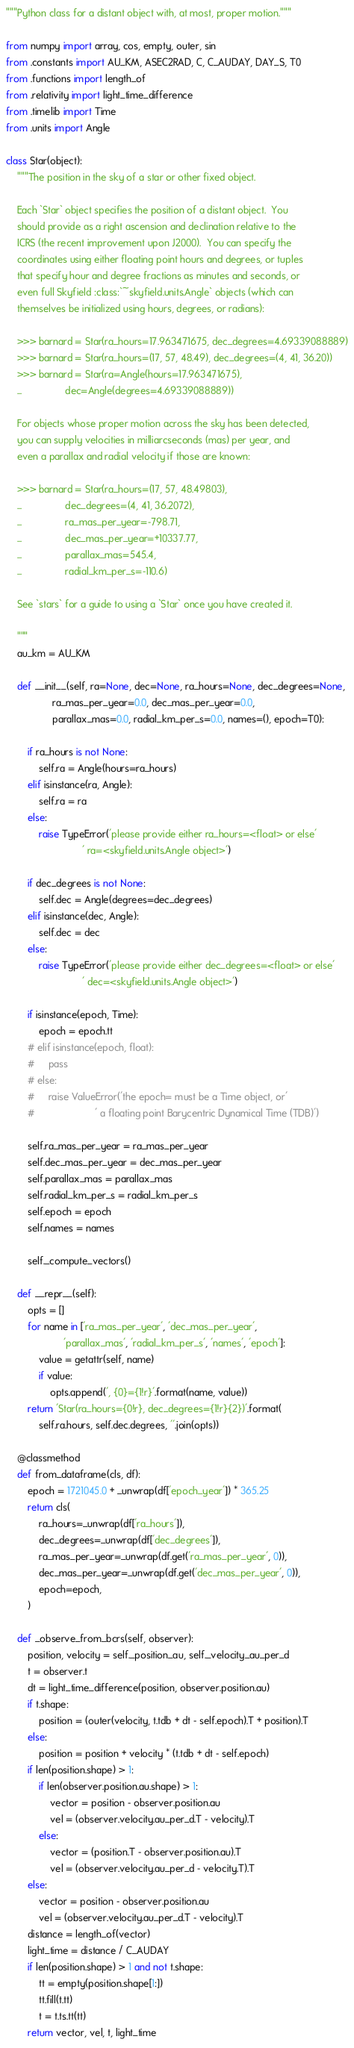Convert code to text. <code><loc_0><loc_0><loc_500><loc_500><_Python_>"""Python class for a distant object with, at most, proper motion."""

from numpy import array, cos, empty, outer, sin
from .constants import AU_KM, ASEC2RAD, C, C_AUDAY, DAY_S, T0
from .functions import length_of
from .relativity import light_time_difference
from .timelib import Time
from .units import Angle

class Star(object):
    """The position in the sky of a star or other fixed object.

    Each `Star` object specifies the position of a distant object.  You
    should provide as a right ascension and declination relative to the
    ICRS (the recent improvement upon J2000).  You can specify the
    coordinates using either floating point hours and degrees, or tuples
    that specify hour and degree fractions as minutes and seconds, or
    even full Skyfield :class:`~skyfield.units.Angle` objects (which can
    themselves be initialized using hours, degrees, or radians):

    >>> barnard = Star(ra_hours=17.963471675, dec_degrees=4.69339088889)
    >>> barnard = Star(ra_hours=(17, 57, 48.49), dec_degrees=(4, 41, 36.20))
    >>> barnard = Star(ra=Angle(hours=17.963471675),
    ...                dec=Angle(degrees=4.69339088889))

    For objects whose proper motion across the sky has been detected,
    you can supply velocities in milliarcseconds (mas) per year, and
    even a parallax and radial velocity if those are known:

    >>> barnard = Star(ra_hours=(17, 57, 48.49803),
    ...                dec_degrees=(4, 41, 36.2072),
    ...                ra_mas_per_year=-798.71,
    ...                dec_mas_per_year=+10337.77,
    ...                parallax_mas=545.4,
    ...                radial_km_per_s=-110.6)

    See `stars` for a guide to using a `Star` once you have created it.

    """
    au_km = AU_KM

    def __init__(self, ra=None, dec=None, ra_hours=None, dec_degrees=None,
                 ra_mas_per_year=0.0, dec_mas_per_year=0.0,
                 parallax_mas=0.0, radial_km_per_s=0.0, names=(), epoch=T0):

        if ra_hours is not None:
            self.ra = Angle(hours=ra_hours)
        elif isinstance(ra, Angle):
            self.ra = ra
        else:
            raise TypeError('please provide either ra_hours=<float> or else'
                            ' ra=<skyfield.units.Angle object>')

        if dec_degrees is not None:
            self.dec = Angle(degrees=dec_degrees)
        elif isinstance(dec, Angle):
            self.dec = dec
        else:
            raise TypeError('please provide either dec_degrees=<float> or else'
                            ' dec=<skyfield.units.Angle object>')

        if isinstance(epoch, Time):
            epoch = epoch.tt
        # elif isinstance(epoch, float):
        #     pass
        # else:
        #     raise ValueError('the epoch= must be a Time object, or'
        #                      ' a floating point Barycentric Dynamical Time (TDB)')

        self.ra_mas_per_year = ra_mas_per_year
        self.dec_mas_per_year = dec_mas_per_year
        self.parallax_mas = parallax_mas
        self.radial_km_per_s = radial_km_per_s
        self.epoch = epoch
        self.names = names

        self._compute_vectors()

    def __repr__(self):
        opts = []
        for name in ['ra_mas_per_year', 'dec_mas_per_year',
                     'parallax_mas', 'radial_km_per_s', 'names', 'epoch']:
            value = getattr(self, name)
            if value:
                opts.append(', {0}={1!r}'.format(name, value))
        return 'Star(ra_hours={0!r}, dec_degrees={1!r}{2})'.format(
            self.ra.hours, self.dec.degrees, ''.join(opts))

    @classmethod
    def from_dataframe(cls, df):
        epoch = 1721045.0 + _unwrap(df['epoch_year']) * 365.25
        return cls(
            ra_hours=_unwrap(df['ra_hours']),
            dec_degrees=_unwrap(df['dec_degrees']),
            ra_mas_per_year=_unwrap(df.get('ra_mas_per_year', 0)),
            dec_mas_per_year=_unwrap(df.get('dec_mas_per_year', 0)),
            epoch=epoch,
        )

    def _observe_from_bcrs(self, observer):
        position, velocity = self._position_au, self._velocity_au_per_d
        t = observer.t
        dt = light_time_difference(position, observer.position.au)
        if t.shape:
            position = (outer(velocity, t.tdb + dt - self.epoch).T + position).T
        else:
            position = position + velocity * (t.tdb + dt - self.epoch)
        if len(position.shape) > 1:
            if len(observer.position.au.shape) > 1:
                vector = position - observer.position.au
                vel = (observer.velocity.au_per_d.T - velocity).T
            else:
                vector = (position.T - observer.position.au).T
                vel = (observer.velocity.au_per_d - velocity.T).T
        else:
            vector = position - observer.position.au
            vel = (observer.velocity.au_per_d.T - velocity).T
        distance = length_of(vector)
        light_time = distance / C_AUDAY
        if len(position.shape) > 1 and not t.shape:
            tt = empty(position.shape[1:])
            tt.fill(t.tt)
            t = t.ts.tt(tt)
        return vector, vel, t, light_time
</code> 